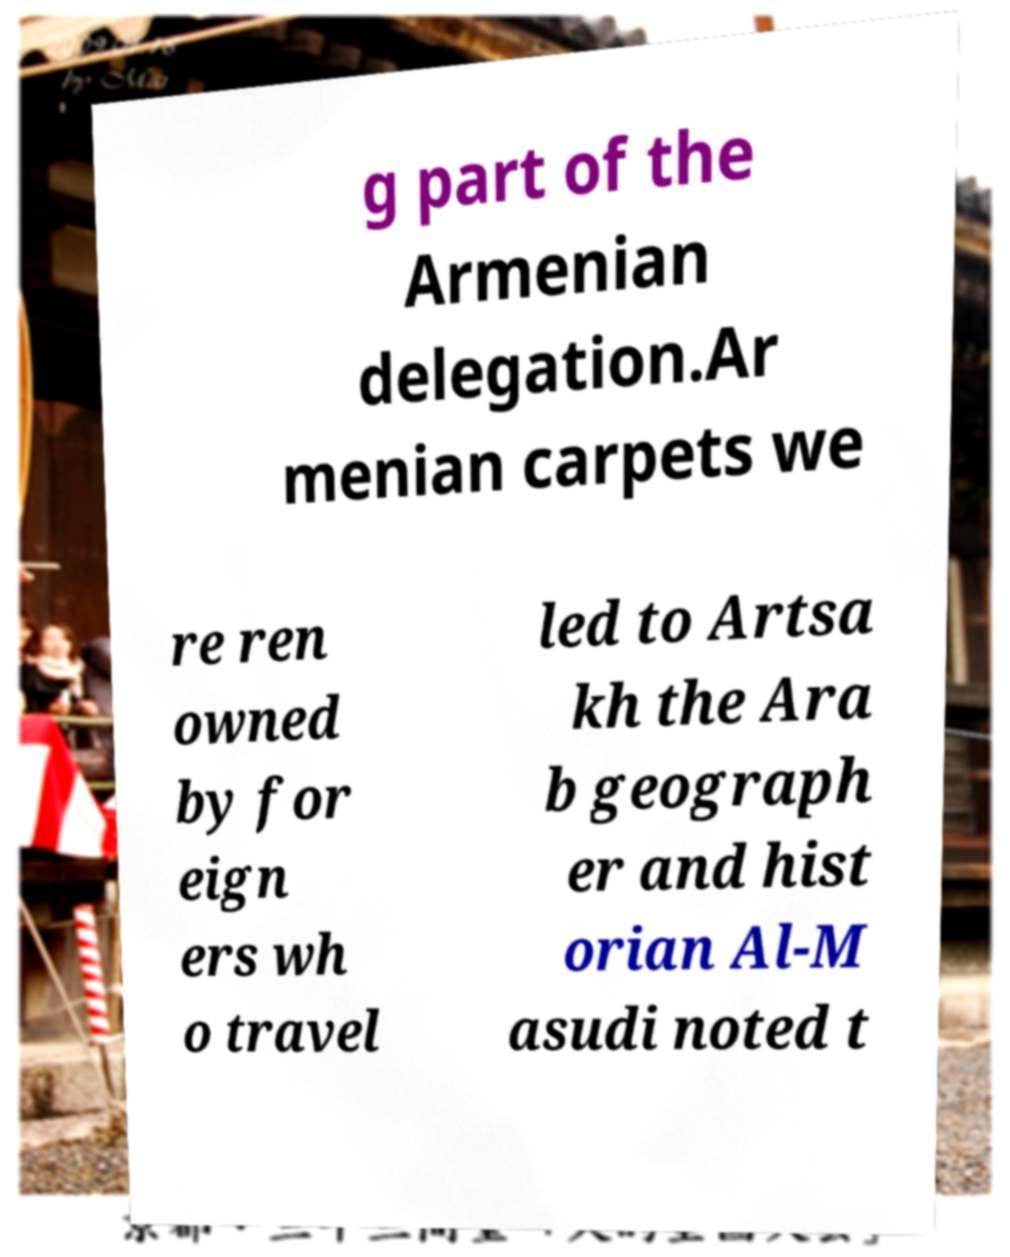For documentation purposes, I need the text within this image transcribed. Could you provide that? g part of the Armenian delegation.Ar menian carpets we re ren owned by for eign ers wh o travel led to Artsa kh the Ara b geograph er and hist orian Al-M asudi noted t 